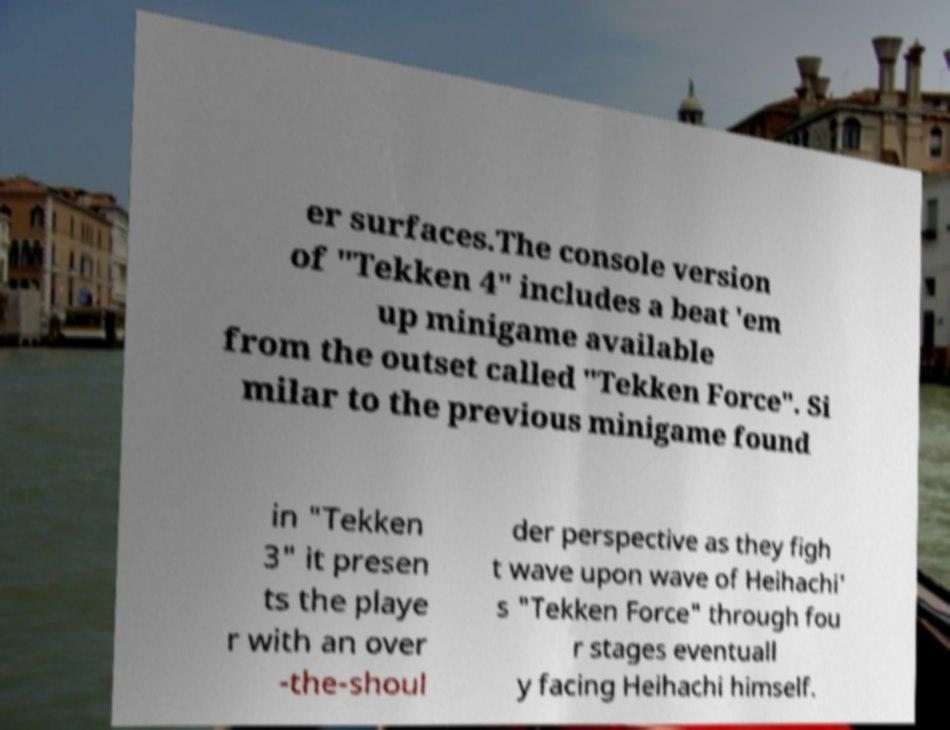Can you read and provide the text displayed in the image?This photo seems to have some interesting text. Can you extract and type it out for me? er surfaces.The console version of "Tekken 4" includes a beat 'em up minigame available from the outset called "Tekken Force". Si milar to the previous minigame found in "Tekken 3" it presen ts the playe r with an over -the-shoul der perspective as they figh t wave upon wave of Heihachi' s "Tekken Force" through fou r stages eventuall y facing Heihachi himself. 